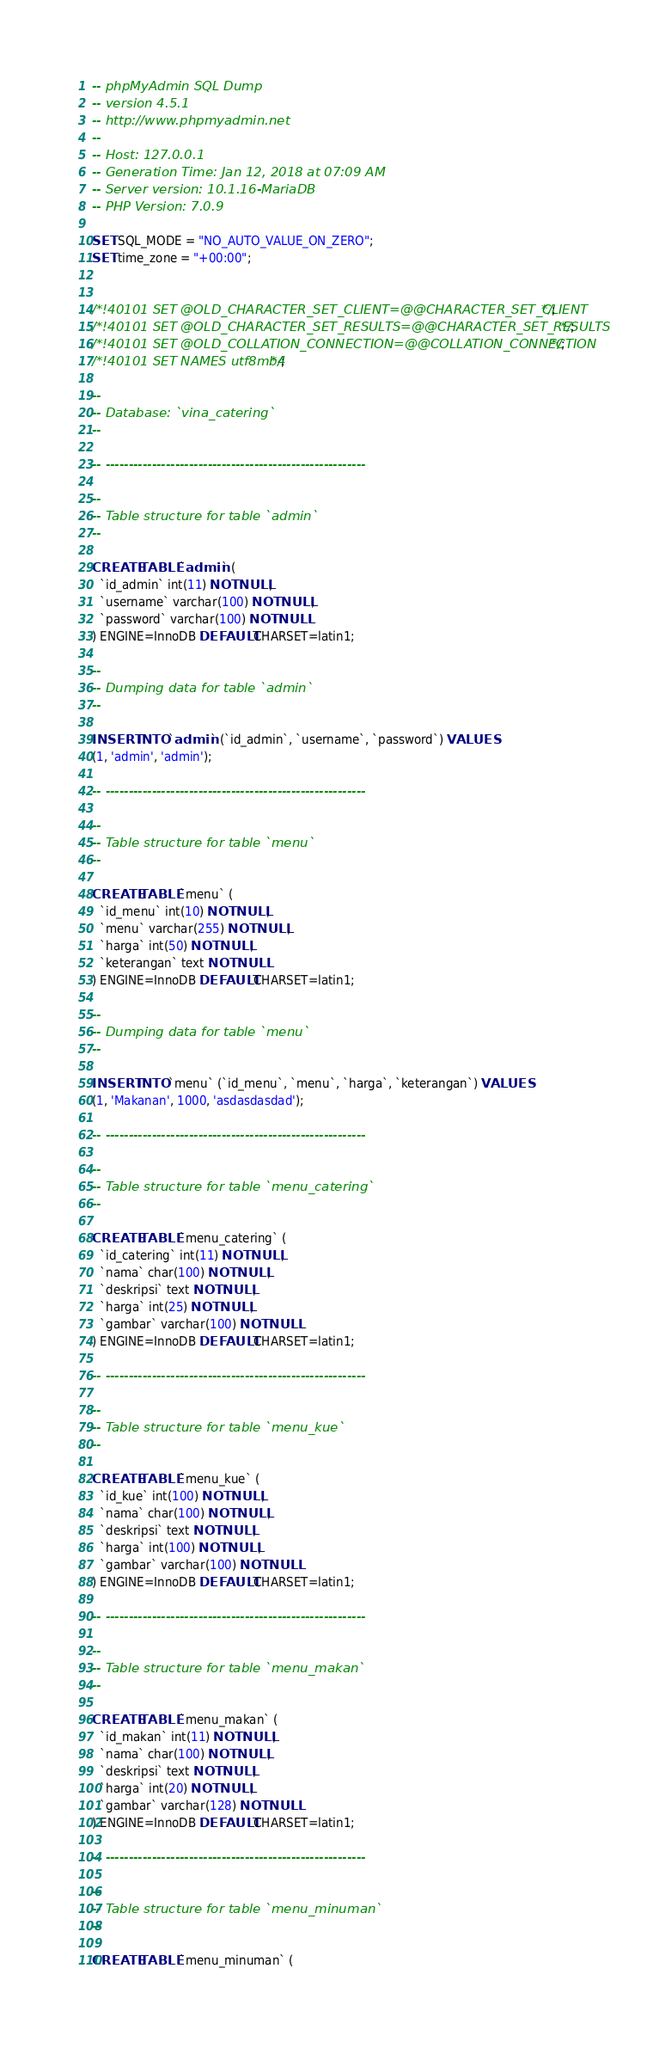<code> <loc_0><loc_0><loc_500><loc_500><_SQL_>-- phpMyAdmin SQL Dump
-- version 4.5.1
-- http://www.phpmyadmin.net
--
-- Host: 127.0.0.1
-- Generation Time: Jan 12, 2018 at 07:09 AM
-- Server version: 10.1.16-MariaDB
-- PHP Version: 7.0.9

SET SQL_MODE = "NO_AUTO_VALUE_ON_ZERO";
SET time_zone = "+00:00";


/*!40101 SET @OLD_CHARACTER_SET_CLIENT=@@CHARACTER_SET_CLIENT */;
/*!40101 SET @OLD_CHARACTER_SET_RESULTS=@@CHARACTER_SET_RESULTS */;
/*!40101 SET @OLD_COLLATION_CONNECTION=@@COLLATION_CONNECTION */;
/*!40101 SET NAMES utf8mb4 */;

--
-- Database: `vina_catering`
--

-- --------------------------------------------------------

--
-- Table structure for table `admin`
--

CREATE TABLE `admin` (
  `id_admin` int(11) NOT NULL,
  `username` varchar(100) NOT NULL,
  `password` varchar(100) NOT NULL
) ENGINE=InnoDB DEFAULT CHARSET=latin1;

--
-- Dumping data for table `admin`
--

INSERT INTO `admin` (`id_admin`, `username`, `password`) VALUES
(1, 'admin', 'admin');

-- --------------------------------------------------------

--
-- Table structure for table `menu`
--

CREATE TABLE `menu` (
  `id_menu` int(10) NOT NULL,
  `menu` varchar(255) NOT NULL,
  `harga` int(50) NOT NULL,
  `keterangan` text NOT NULL
) ENGINE=InnoDB DEFAULT CHARSET=latin1;

--
-- Dumping data for table `menu`
--

INSERT INTO `menu` (`id_menu`, `menu`, `harga`, `keterangan`) VALUES
(1, 'Makanan', 1000, 'asdasdasdad');

-- --------------------------------------------------------

--
-- Table structure for table `menu_catering`
--

CREATE TABLE `menu_catering` (
  `id_catering` int(11) NOT NULL,
  `nama` char(100) NOT NULL,
  `deskripsi` text NOT NULL,
  `harga` int(25) NOT NULL,
  `gambar` varchar(100) NOT NULL
) ENGINE=InnoDB DEFAULT CHARSET=latin1;

-- --------------------------------------------------------

--
-- Table structure for table `menu_kue`
--

CREATE TABLE `menu_kue` (
  `id_kue` int(100) NOT NULL,
  `nama` char(100) NOT NULL,
  `deskripsi` text NOT NULL,
  `harga` int(100) NOT NULL,
  `gambar` varchar(100) NOT NULL
) ENGINE=InnoDB DEFAULT CHARSET=latin1;

-- --------------------------------------------------------

--
-- Table structure for table `menu_makan`
--

CREATE TABLE `menu_makan` (
  `id_makan` int(11) NOT NULL,
  `nama` char(100) NOT NULL,
  `deskripsi` text NOT NULL,
  `harga` int(20) NOT NULL,
  `gambar` varchar(128) NOT NULL
) ENGINE=InnoDB DEFAULT CHARSET=latin1;

-- --------------------------------------------------------

--
-- Table structure for table `menu_minuman`
--

CREATE TABLE `menu_minuman` (</code> 